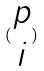Convert formula to latex. <formula><loc_0><loc_0><loc_500><loc_500>( \begin{matrix} p \\ i \end{matrix} )</formula> 